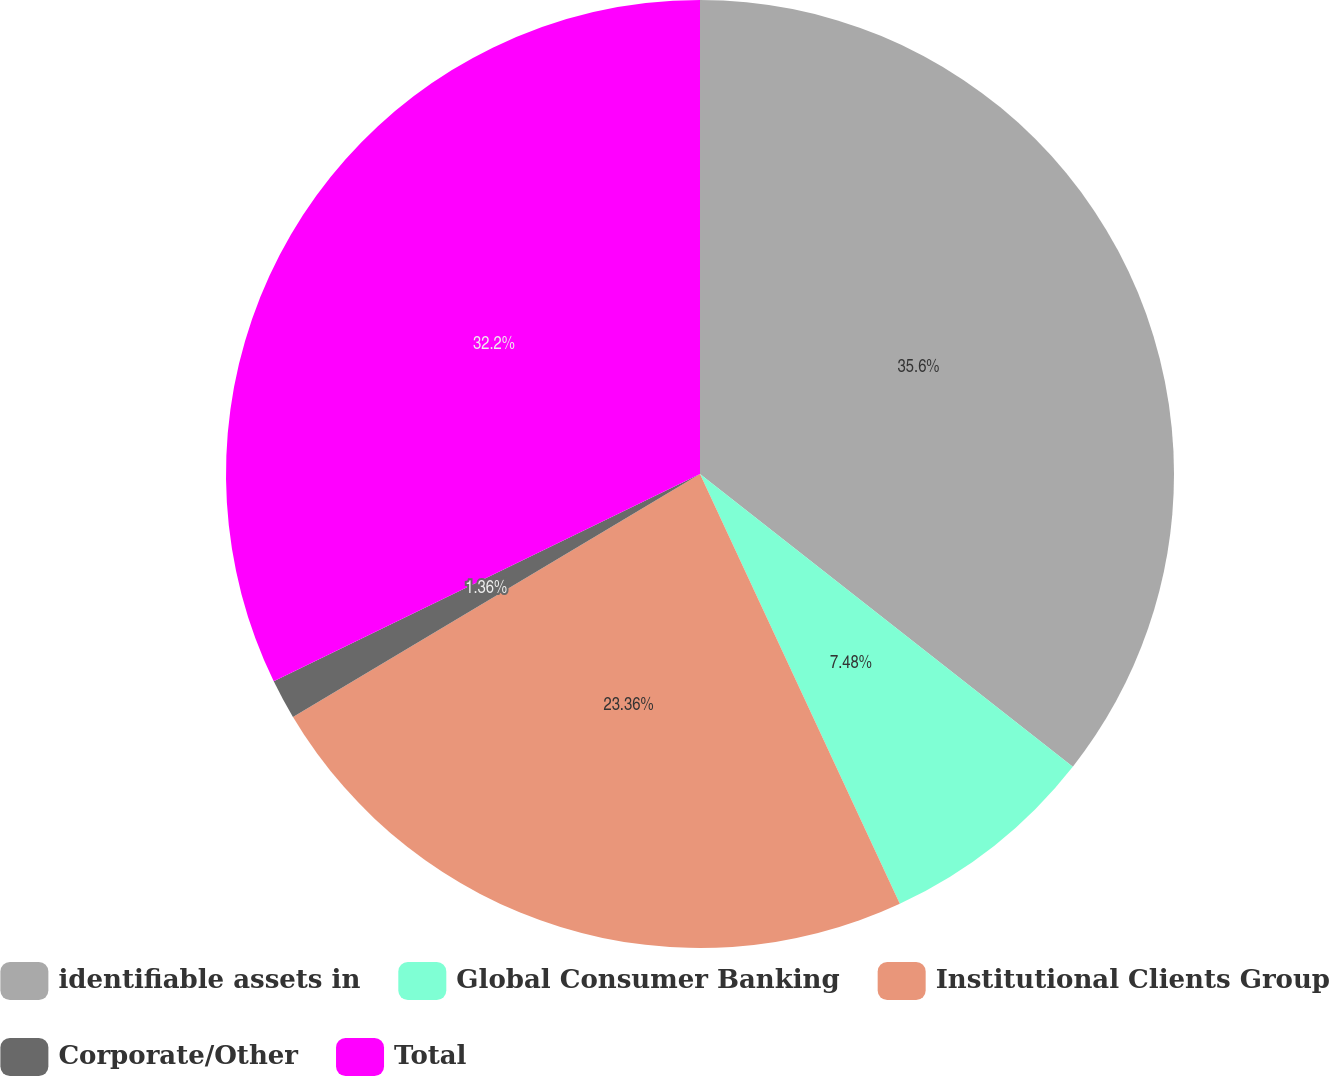<chart> <loc_0><loc_0><loc_500><loc_500><pie_chart><fcel>identifiable assets in<fcel>Global Consumer Banking<fcel>Institutional Clients Group<fcel>Corporate/Other<fcel>Total<nl><fcel>35.59%<fcel>7.48%<fcel>23.36%<fcel>1.36%<fcel>32.2%<nl></chart> 